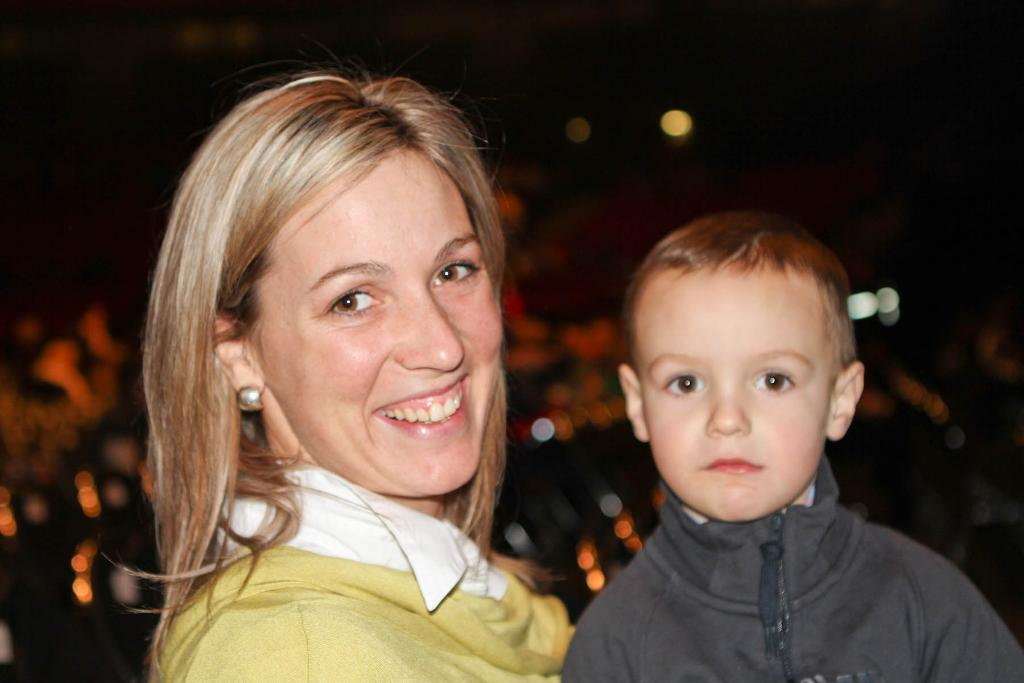Who is present in the image? There is a woman and a child in the image. What is the woman doing in the image? The woman is smiling in the image. What can be seen in the background of the image? There are lights visible in the background of the image, and the background is dark. What type of soup is being served in the image? There is no soup present in the image. Can you tell me how many cacti are visible in the image? There are no cacti visible in the image. 